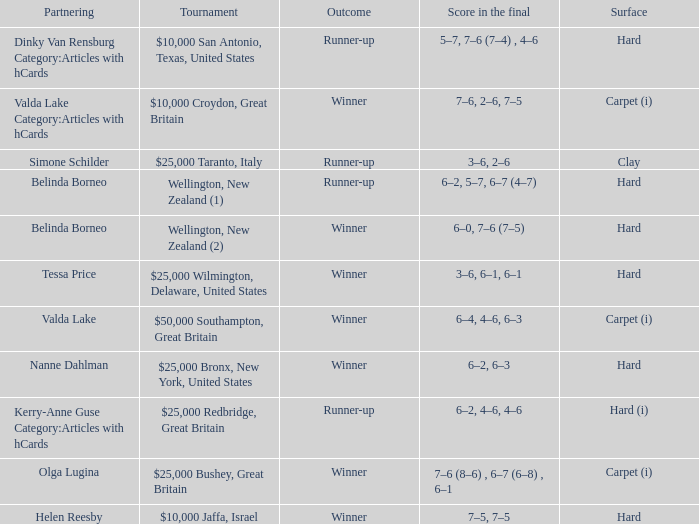What was the final score for the match with a partnering of Tessa Price? 3–6, 6–1, 6–1. 